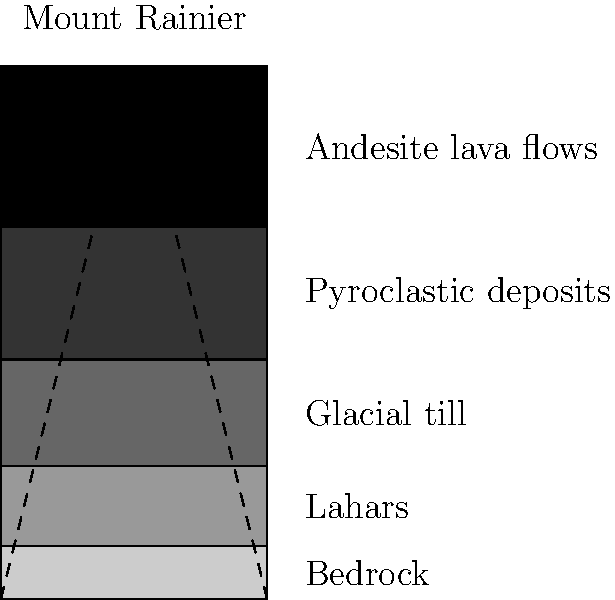Analyze the cross-sectional diagram of Mount Rainier's geological layers. Which layer is most likely to pose the greatest risk for lahars (volcanic mudflows) during future eruptions, and why is this significant for the surrounding Pacific Northwest communities? To answer this question, let's analyze the layers of Mount Rainier from top to bottom:

1. Andesite lava flows: The topmost layer, typical of stratovolcanoes like Mount Rainier.
2. Pyroclastic deposits: Loose volcanic materials from previous eruptions.
3. Glacial till: Debris left behind by glaciers.
4. Lahars: Previous volcanic mudflows.
5. Bedrock: The solid rock foundation.

The layer posing the greatest risk for future lahars is the pyroclastic deposits layer. Here's why:

1. Composition: Pyroclastic deposits consist of loose, unconsolidated materials like ash, pumice, and rock fragments.
2. Instability: These deposits are not well-compacted and can easily be mobilized by water or seismic activity.
3. Location: Being near the summit, they are more susceptible to disturbance during eruptions or heavy rainfall.
4. Historical precedent: Previous lahars have often originated from the remobilization of pyroclastic deposits.

Significance for Pacific Northwest communities:

1. Danger zone: Communities in river valleys downstream from Mount Rainier are at risk.
2. Rapid movement: Lahars can move quickly, giving little time for evacuation.
3. Widespread impact: Lahars can travel long distances, affecting areas far from the volcano.
4. Economic consequences: Destruction of infrastructure and property in affected areas.
5. Long-term effects: Lahar deposits can alter landscapes and ecosystems for years.

Understanding this risk is crucial for emergency preparedness, land-use planning, and public education in the Pacific Northwest region.
Answer: Pyroclastic deposits layer; high instability and potential for mobilization during eruptions or heavy rainfall, posing significant risks to downstream communities. 